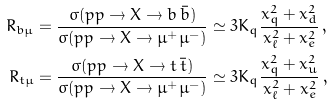<formula> <loc_0><loc_0><loc_500><loc_500>R _ { b \mu } & = \frac { \sigma ( p p \rightarrow X \rightarrow b \, \bar { b } ) } { \sigma ( p p \rightarrow X \rightarrow \mu ^ { + } \mu ^ { - } ) } \simeq 3 K _ { q } \frac { x _ { q } ^ { 2 } + x _ { d } ^ { 2 } } { x _ { \ell } ^ { 2 } + x _ { e } ^ { 2 } } \, , \\ R _ { t \mu } & = \frac { \sigma ( p p \rightarrow X \rightarrow t \, \bar { t } ) } { \sigma ( p p \rightarrow X \rightarrow \mu ^ { + } \mu ^ { - } ) } \simeq 3 K _ { q } \frac { x _ { q } ^ { 2 } + x _ { u } ^ { 2 } } { x _ { \ell } ^ { 2 } + x _ { e } ^ { 2 } } \, ,</formula> 